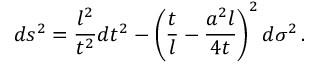Convert formula to latex. <formula><loc_0><loc_0><loc_500><loc_500>d s ^ { 2 } = \frac { l ^ { 2 } } { t ^ { 2 } } d t ^ { 2 } - \left ( \frac { t } { l } - \frac { a ^ { 2 } l } { 4 t } \right ) ^ { 2 } d \sigma ^ { 2 } \, .</formula> 